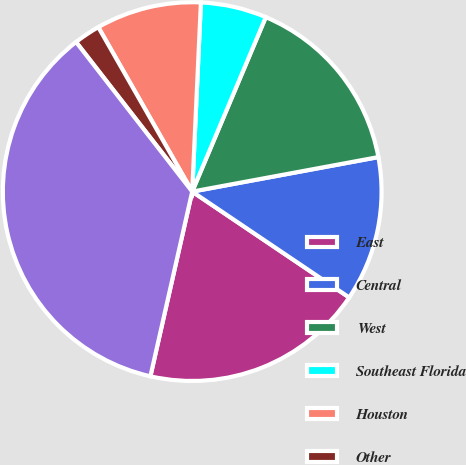Convert chart to OTSL. <chart><loc_0><loc_0><loc_500><loc_500><pie_chart><fcel>East<fcel>Central<fcel>West<fcel>Southeast Florida<fcel>Houston<fcel>Other<fcel>Total<nl><fcel>19.1%<fcel>12.36%<fcel>15.73%<fcel>5.62%<fcel>8.99%<fcel>2.25%<fcel>35.95%<nl></chart> 